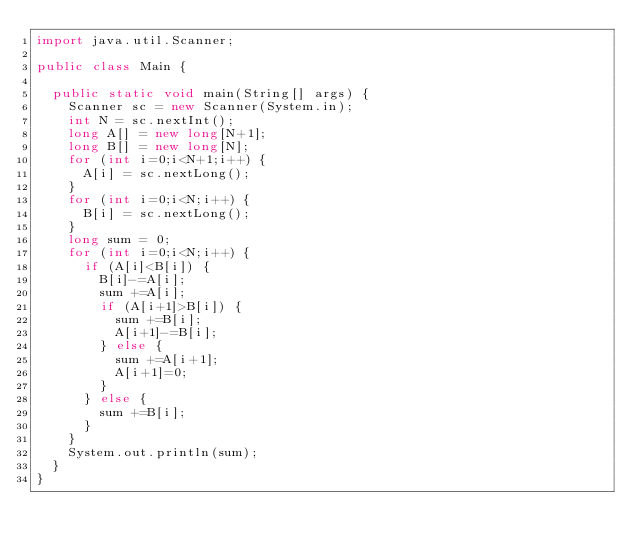Convert code to text. <code><loc_0><loc_0><loc_500><loc_500><_Java_>import java.util.Scanner;

public class Main {

	public static void main(String[] args) {
		Scanner sc = new Scanner(System.in);
		int N = sc.nextInt();
		long A[] = new long[N+1];
		long B[] = new long[N];
		for (int i=0;i<N+1;i++) {
			A[i] = sc.nextLong();
		}
		for (int i=0;i<N;i++) {
			B[i] = sc.nextLong();
		}
		long sum = 0;
		for (int i=0;i<N;i++) {
			if (A[i]<B[i]) {
				B[i]-=A[i];
				sum +=A[i];
				if (A[i+1]>B[i]) {
					sum +=B[i];
					A[i+1]-=B[i];
				} else {
					sum +=A[i+1];
					A[i+1]=0;
				}
			} else {
				sum +=B[i];
			}
		}
		System.out.println(sum);
	}
}
</code> 